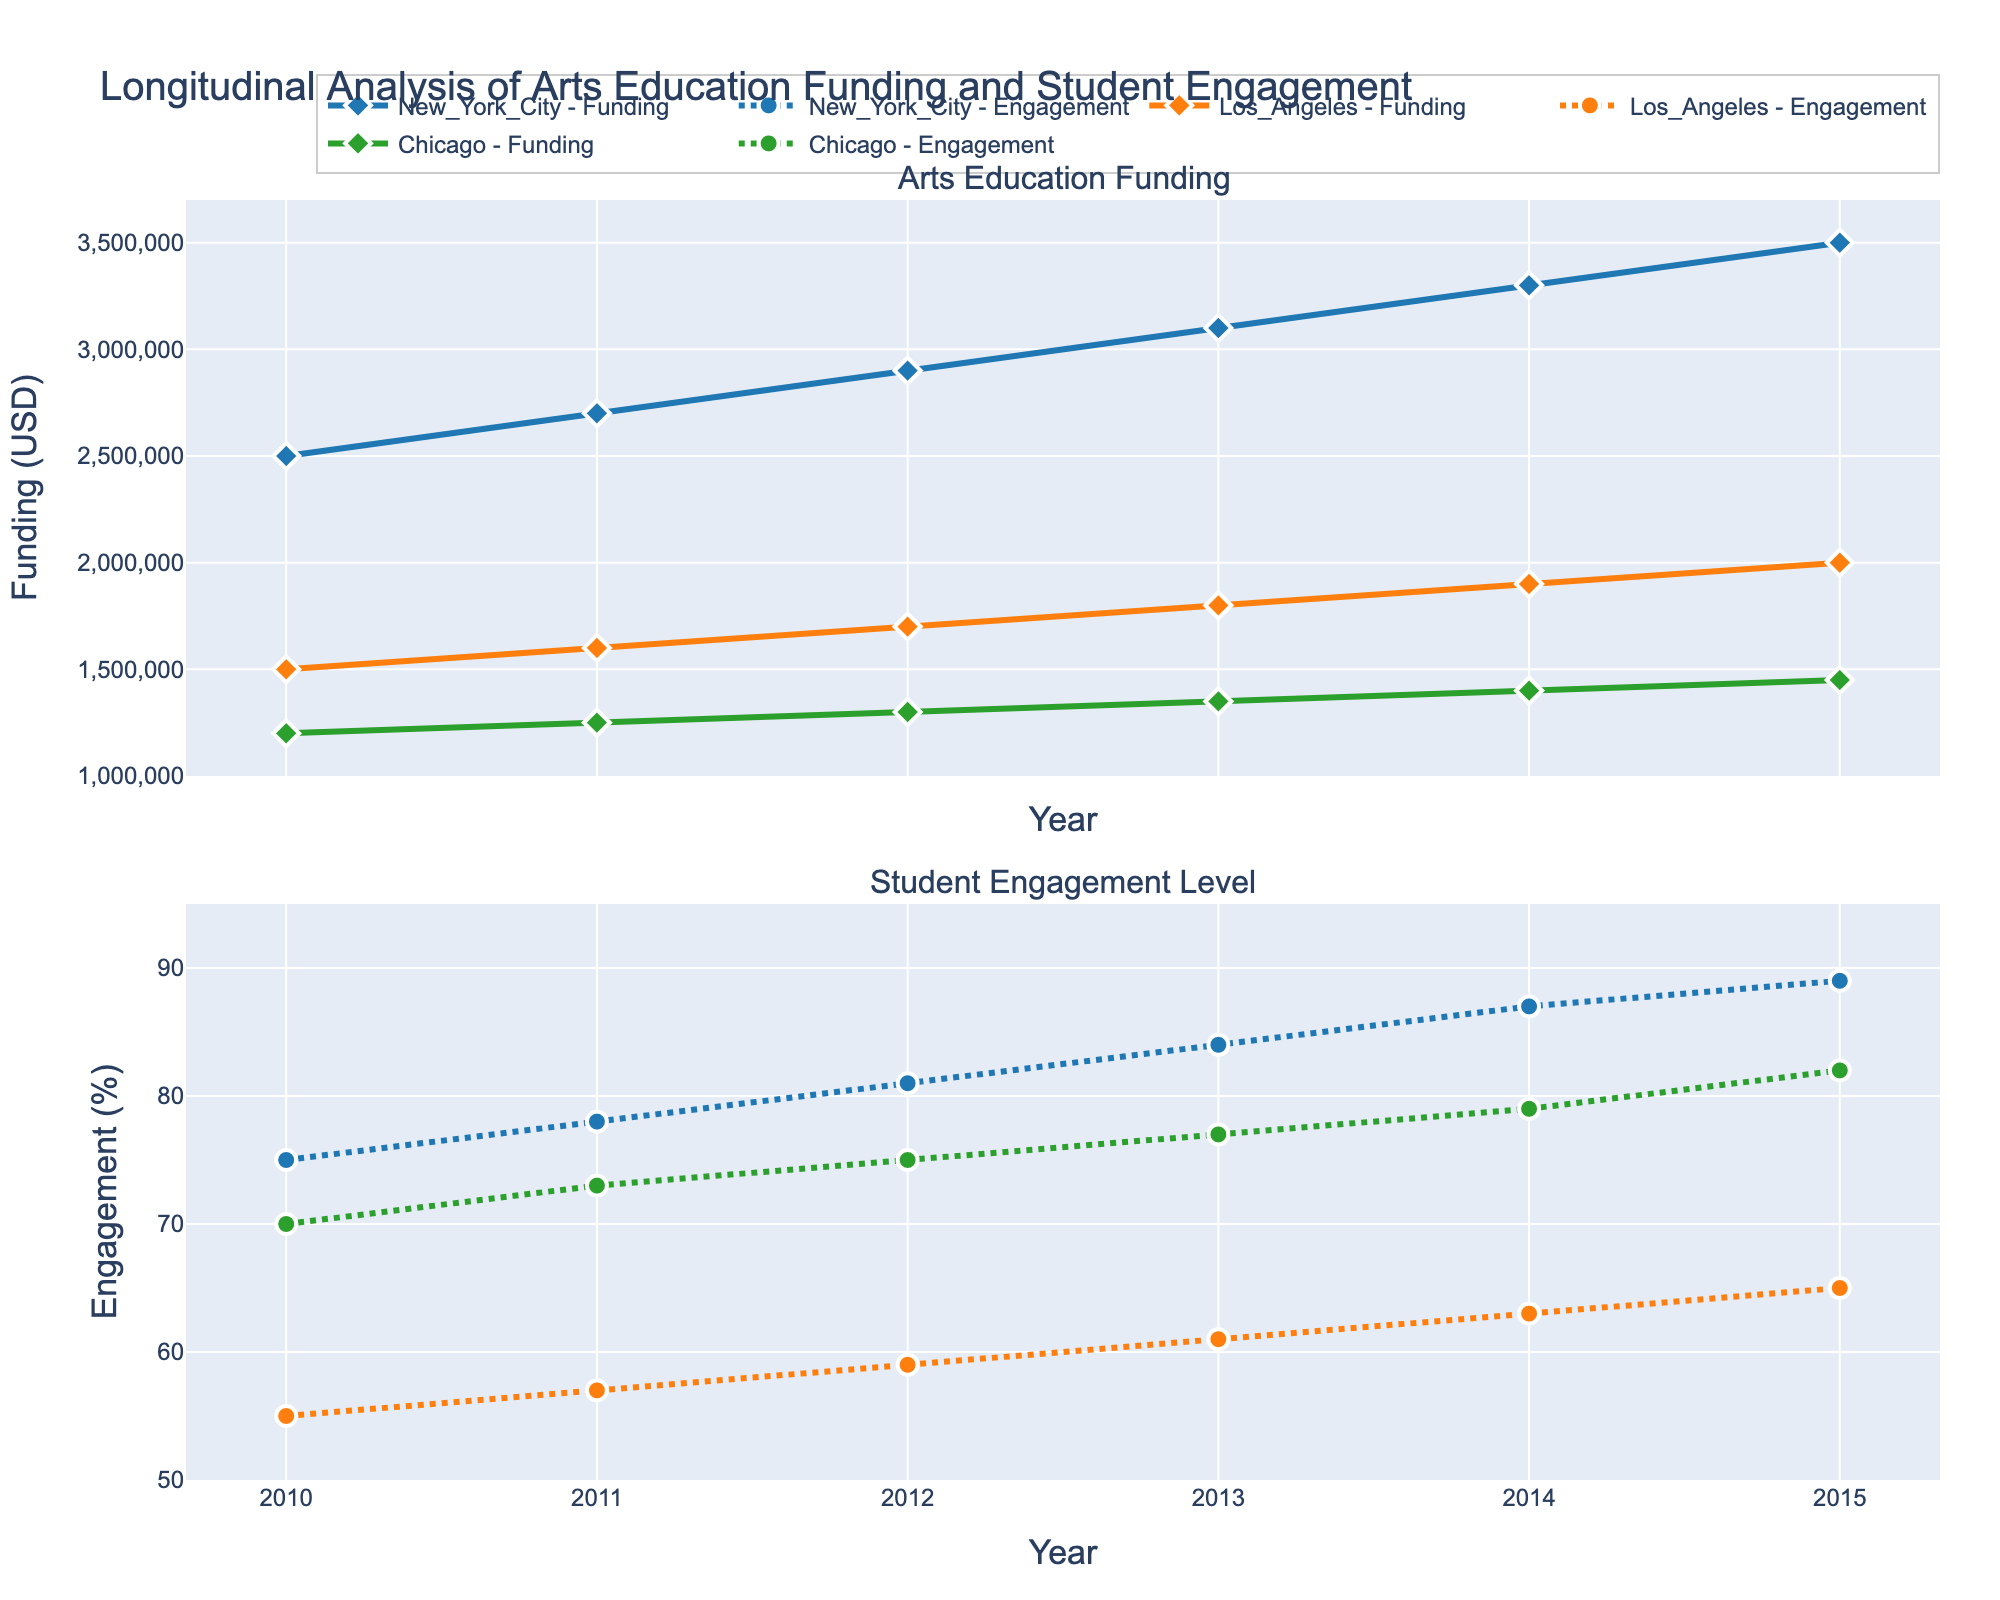What is the title of the figure? The title is typically displayed at the top of the plot. It is indicated in the layout settings.
Answer: Longitudinal Analysis of Arts Education Funding and Student Engagement How many school districts are represented in the figure? We can identify the number of distinct school districts by looking for unique names associated with different data lines. There are traces for three different school districts.
Answer: Three Which school district had the highest student engagement level in 2015? To answer this, locate the 2015 data points in the "Student Engagement Level" subplot and identify which district's value is the highest.
Answer: New York City What was the total arts education funding for Los Angeles in 2013? Find the 2013 data point in the "Arts Education Funding" subplot for Los Angeles.
Answer: $1,800,000 Compare the percent increase in student engagement level from 2010 to 2015 for New York City and Chicago. Calculate the percent increase for both districts: \
For New York City: ((89 - 75) / 75) * 100 = 18.67% \
For Chicago: ((82 - 70) / 70) * 100 = 17.14%
Answer: New York City had a higher percent increase What is the difference in total arts education funding between New York City and Los Angeles in 2012? Find the funding for both districts in 2012 and subtract the value for Los Angeles from that for New York City.
Answer: $1,200,000 Which school district had a steady increase in student engagement every year from 2010 to 2015? Check the "Student Engagement Level" subplot and observe the trends. New York City and Chicago both show a steady increase each year without any decrease.
Answer: New York City and Chicago What trend can be observed in the relationship between funding and student engagement level for Los Angeles from 2010 to 2015? By comparing both subplots for Los Angeles, we can see that as funding increased, the student engagement level also increased.
Answer: Increasing funding is associated with increasing engagement What was the average student engagement level for Chicago over the years provided? Sum the engagement levels for Chicago from 2010 to 2015 and divide by the number of years: (70 + 73 + 75 + 77 + 79 + 82) / 6 = 76
Answer: 76 Which year had the smallest gap in total arts education funding between New York City and Los Angeles? Calculate the differences in funding for each year and identify the smallest gap. For example: \
2010: $1,000,000 \
2011: $1,100,000 \
2012: $1,200,000 \
2013: $1,300,000 \
2014: $1,400,000 \
2015: $1,500,000
Answer: 2010 